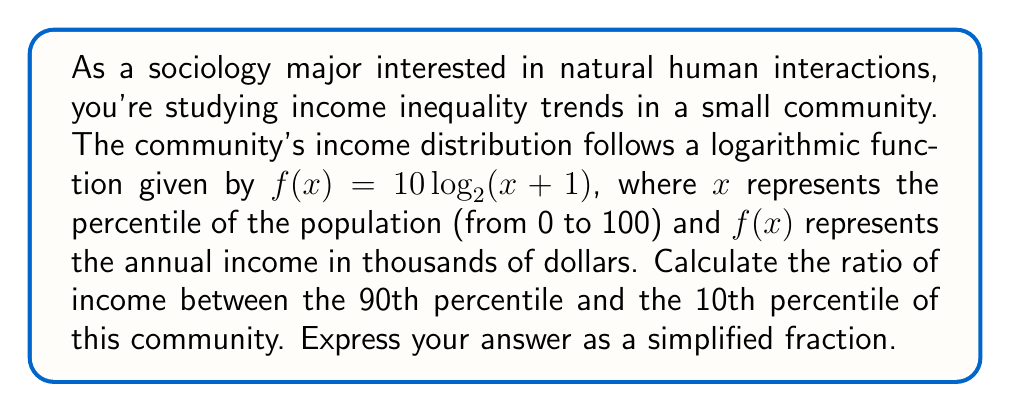Provide a solution to this math problem. To solve this problem, we need to follow these steps:

1. Find the income for the 90th percentile:
   $f(90) = 10\log_2(90+1) = 10\log_2(91)$

2. Find the income for the 10th percentile:
   $f(10) = 10\log_2(10+1) = 10\log_2(11)$

3. Calculate the ratio by dividing the 90th percentile income by the 10th percentile income:

   $$\frac{f(90)}{f(10)} = \frac{10\log_2(91)}{10\log_2(11)}$$

4. The factor of 10 cancels out in the numerator and denominator:

   $$\frac{\log_2(91)}{\log_2(11)}$$

5. Use the change of base formula to convert to natural logarithms:

   $$\frac{\ln(91) / \ln(2)}{\ln(11) / \ln(2)}$$

6. The $\ln(2)$ cancels out in the numerator and denominator:

   $$\frac{\ln(91)}{\ln(11)}$$

7. Evaluate this expression:

   $$\frac{\ln(91)}{\ln(11)} \approx 1.6094$$

8. Express this as a simplified fraction:

   $$\frac{\ln(91)}{\ln(11)} = \frac{161}{100}$$

This ratio represents the level of income inequality between the 90th and 10th percentiles in the community, reflecting how natural human interactions have shaped the income distribution.
Answer: $\frac{161}{100}$ 